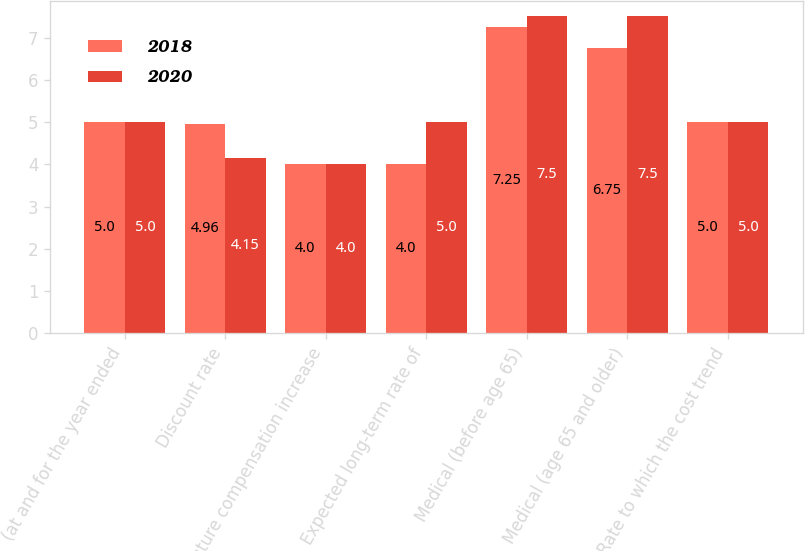Convert chart to OTSL. <chart><loc_0><loc_0><loc_500><loc_500><stacked_bar_chart><ecel><fcel>(at and for the year ended<fcel>Discount rate<fcel>Future compensation increase<fcel>Expected long-term rate of<fcel>Medical (before age 65)<fcel>Medical (age 65 and older)<fcel>Rate to which the cost trend<nl><fcel>2018<fcel>5<fcel>4.96<fcel>4<fcel>4<fcel>7.25<fcel>6.75<fcel>5<nl><fcel>2020<fcel>5<fcel>4.15<fcel>4<fcel>5<fcel>7.5<fcel>7.5<fcel>5<nl></chart> 